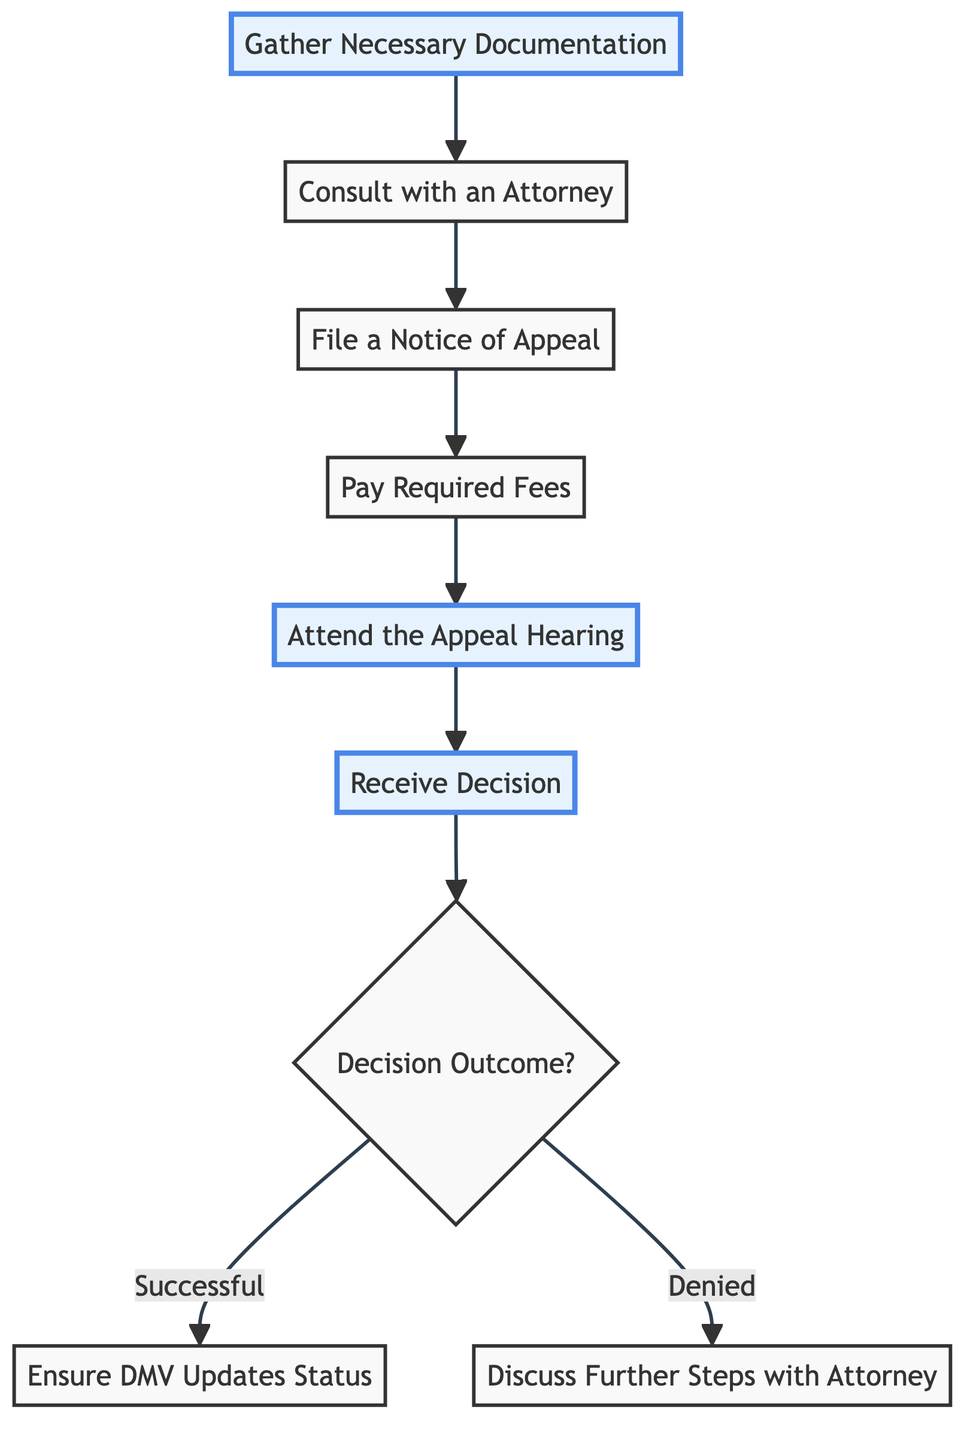What is the first step in the diagram? The first node in the flowchart is labeled "Gather Necessary Documentation," which indicates it as the initial step that one must take in the appeal process for a suspended driver's license.
Answer: Gather Necessary Documentation How many steps are there in total? Counting all the distinct steps in the flowchart from "Gather Necessary Documentation" to "Discuss Further Steps with Attorney", there are a total of 7 steps depicted in the diagram.
Answer: 7 What is the last step if the appeal is successful? From the decision outcome labeled "Successful," the following step is "Ensure DMV Updates Status," signifying the actions to be taken post a successful appeal.
Answer: Ensure DMV Updates Status Which step follows "File a Notice of Appeal"? After "File a Notice of Appeal," the next step in the diagram is "Pay Required Fees," indicating the order of actions to be taken in the process.
Answer: Pay Required Fees What is the outcome if the appeal is denied? If the decision outcome is "Denied," the arrow leads to the step labeled "Discuss Further Steps with Attorney," showing the action that needs to be taken following a denied appeal.
Answer: Discuss Further Steps with Attorney What is the purpose of the "Consult with an Attorney" step? The "Consult with an Attorney" step serves to schedule a meeting with a traffic law attorney who can provide guidance and review your case regarding the appeal process.
Answer: Expert advice What type of fee is mentioned in the diagram? The diagram mentions "Any required filing fees," which refers to the financial obligations needed to proceed with the appeal process.
Answer: Filing fees What happens after "Attend the Appeal Hearing"? Once "Attend the Appeal Hearing" is completed, the next step is "Receive Decision," showcasing the sequence of actions leading to the outcome of the appeal.
Answer: Receive Decision What are the two possible outcomes after receiving the decision? After receiving the decision, the flowchart indicates two possibilities: "Successful" and "Denied," representing the two outcomes of the appeal process.
Answer: Successful, Denied 